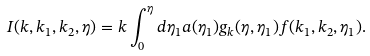<formula> <loc_0><loc_0><loc_500><loc_500>I ( k , k _ { 1 } , k _ { 2 } , \eta ) = k \int _ { 0 } ^ { \eta } d \eta _ { 1 } a ( \eta _ { 1 } ) g _ { k } ( \eta , \eta _ { 1 } ) f ( k _ { 1 } , k _ { 2 } , \eta _ { 1 } ) .</formula> 